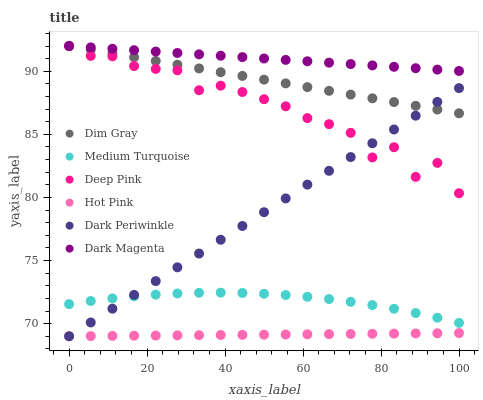Does Hot Pink have the minimum area under the curve?
Answer yes or no. Yes. Does Dark Magenta have the maximum area under the curve?
Answer yes or no. Yes. Does Dark Magenta have the minimum area under the curve?
Answer yes or no. No. Does Hot Pink have the maximum area under the curve?
Answer yes or no. No. Is Hot Pink the smoothest?
Answer yes or no. Yes. Is Deep Pink the roughest?
Answer yes or no. Yes. Is Dark Magenta the smoothest?
Answer yes or no. No. Is Dark Magenta the roughest?
Answer yes or no. No. Does Hot Pink have the lowest value?
Answer yes or no. Yes. Does Dark Magenta have the lowest value?
Answer yes or no. No. Does Deep Pink have the highest value?
Answer yes or no. Yes. Does Hot Pink have the highest value?
Answer yes or no. No. Is Medium Turquoise less than Deep Pink?
Answer yes or no. Yes. Is Dark Magenta greater than Hot Pink?
Answer yes or no. Yes. Does Dim Gray intersect Deep Pink?
Answer yes or no. Yes. Is Dim Gray less than Deep Pink?
Answer yes or no. No. Is Dim Gray greater than Deep Pink?
Answer yes or no. No. Does Medium Turquoise intersect Deep Pink?
Answer yes or no. No. 